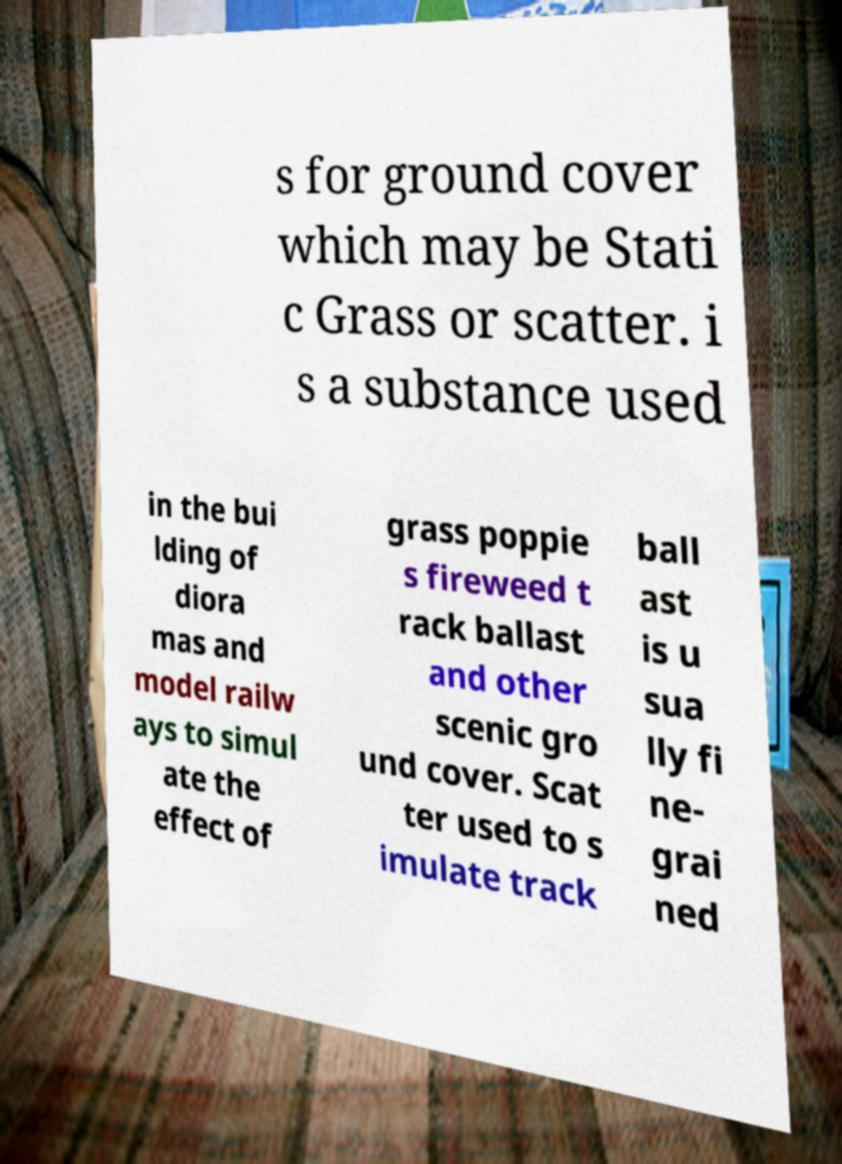Can you accurately transcribe the text from the provided image for me? s for ground cover which may be Stati c Grass or scatter. i s a substance used in the bui lding of diora mas and model railw ays to simul ate the effect of grass poppie s fireweed t rack ballast and other scenic gro und cover. Scat ter used to s imulate track ball ast is u sua lly fi ne- grai ned 